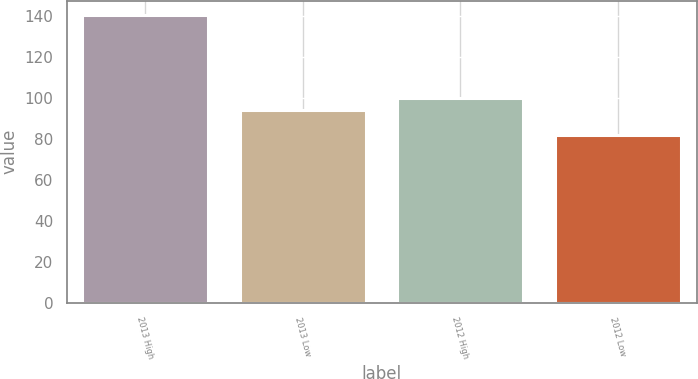Convert chart to OTSL. <chart><loc_0><loc_0><loc_500><loc_500><bar_chart><fcel>2013 High<fcel>2013 Low<fcel>2012 High<fcel>2012 Low<nl><fcel>140.43<fcel>93.96<fcel>99.8<fcel>81.99<nl></chart> 